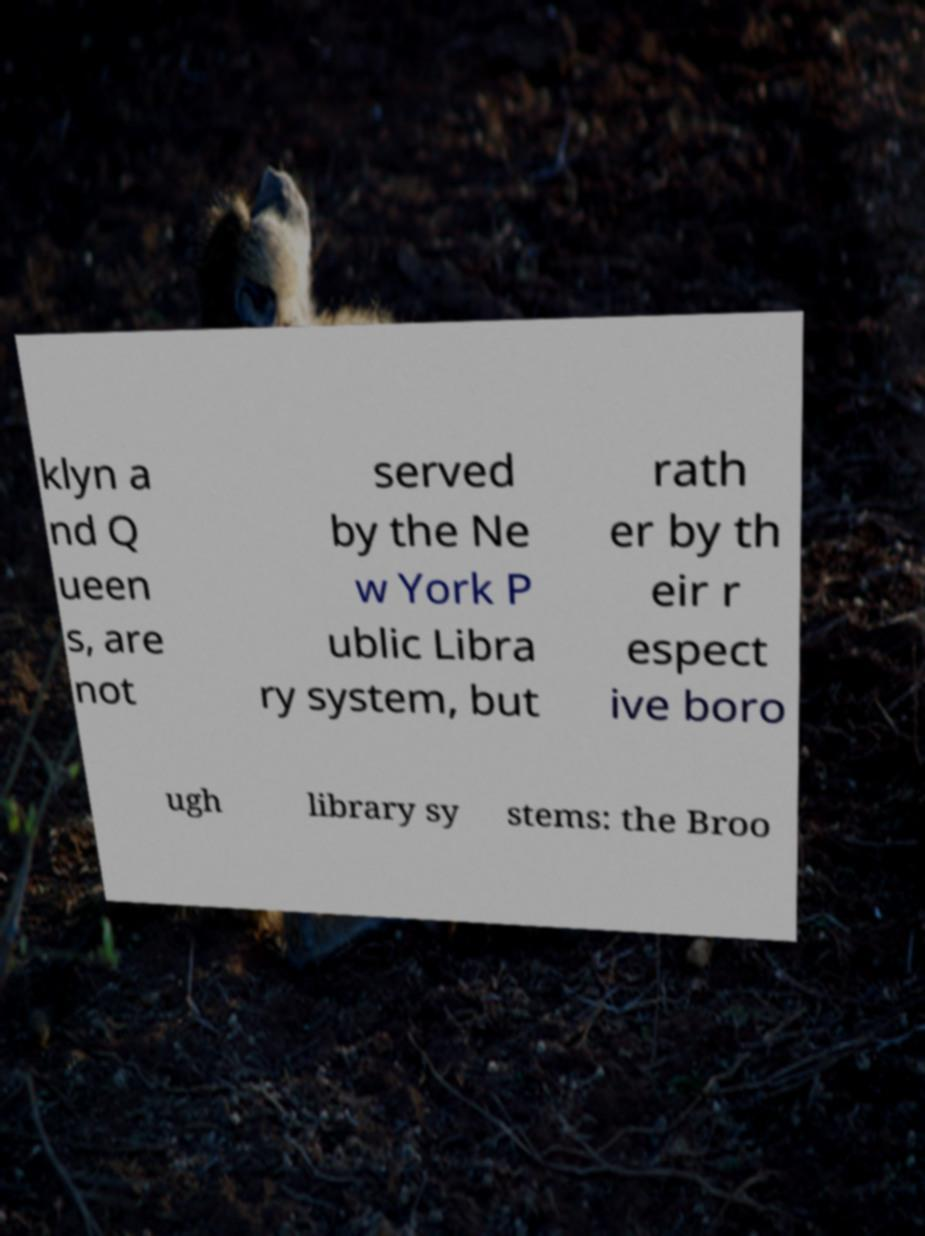I need the written content from this picture converted into text. Can you do that? klyn a nd Q ueen s, are not served by the Ne w York P ublic Libra ry system, but rath er by th eir r espect ive boro ugh library sy stems: the Broo 